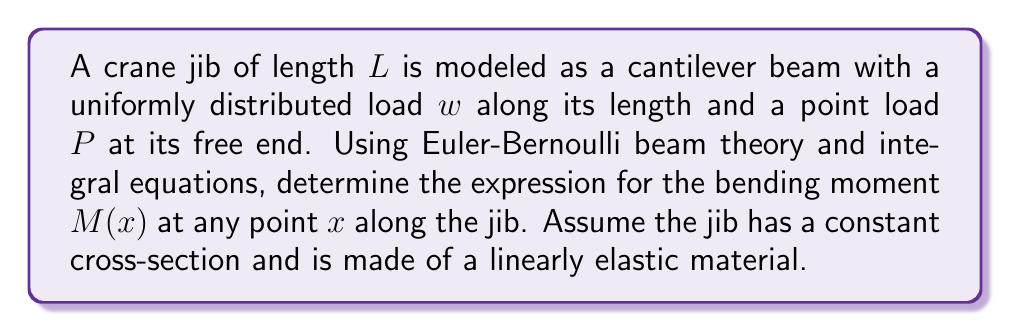Help me with this question. To solve this problem, we'll follow these steps:

1) First, we need to establish the differential equation for the beam deflection:

   $$\frac{d^2y}{dx^2} = -\frac{M(x)}{EI}$$

   Where $y$ is the deflection, $E$ is the Young's modulus, and $I$ is the moment of inertia.

2) Next, we'll consider the loading conditions. The total load at any point $x$ is the sum of the distributed load and the point load:

   $$q(x) = w + P\delta(x-L)$$

   Where $\delta$ is the Dirac delta function.

3) The relationship between the distributed load and the shear force is:

   $$\frac{dV}{dx} = -q(x)$$

4) Integrating this equation:

   $$V(x) = -\int_0^x q(t)dt = -wx - P[H(x-L)]$$

   Where $H$ is the Heaviside step function.

5) The relationship between shear force and bending moment is:

   $$\frac{dM}{dx} = V(x)$$

6) Integrating this equation:

   $$M(x) = \int_0^x V(t)dt = -\frac{wx^2}{2} - P(x-L)[H(x-L)]$$

7) Simplifying for $x \le L$:

   $$M(x) = -\frac{wx^2}{2} - P(x-L)$$

This gives us the expression for the bending moment at any point $x$ along the jib.
Answer: $M(x) = -\frac{wx^2}{2} - P(x-L)$ 